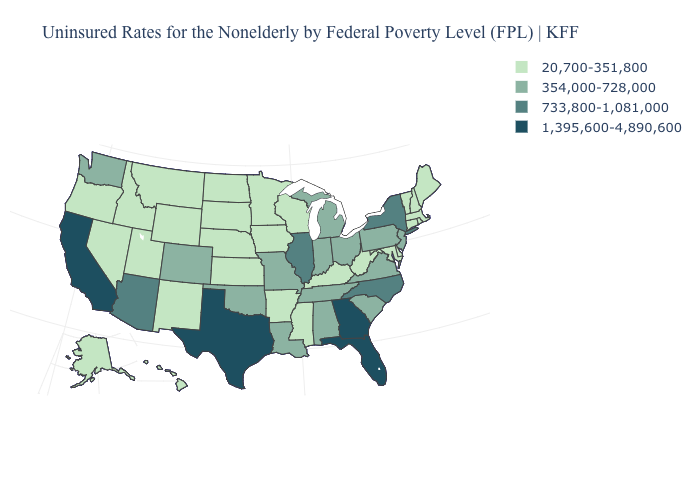Name the states that have a value in the range 354,000-728,000?
Be succinct. Alabama, Colorado, Indiana, Louisiana, Michigan, Missouri, New Jersey, Ohio, Oklahoma, Pennsylvania, South Carolina, Tennessee, Virginia, Washington. Name the states that have a value in the range 354,000-728,000?
Short answer required. Alabama, Colorado, Indiana, Louisiana, Michigan, Missouri, New Jersey, Ohio, Oklahoma, Pennsylvania, South Carolina, Tennessee, Virginia, Washington. Name the states that have a value in the range 1,395,600-4,890,600?
Keep it brief. California, Florida, Georgia, Texas. What is the value of Colorado?
Write a very short answer. 354,000-728,000. What is the value of Idaho?
Be succinct. 20,700-351,800. Name the states that have a value in the range 1,395,600-4,890,600?
Keep it brief. California, Florida, Georgia, Texas. What is the highest value in the USA?
Give a very brief answer. 1,395,600-4,890,600. What is the lowest value in the USA?
Short answer required. 20,700-351,800. Among the states that border Colorado , which have the lowest value?
Answer briefly. Kansas, Nebraska, New Mexico, Utah, Wyoming. What is the value of Idaho?
Be succinct. 20,700-351,800. What is the highest value in the West ?
Be succinct. 1,395,600-4,890,600. Which states have the lowest value in the USA?
Keep it brief. Alaska, Arkansas, Connecticut, Delaware, Hawaii, Idaho, Iowa, Kansas, Kentucky, Maine, Maryland, Massachusetts, Minnesota, Mississippi, Montana, Nebraska, Nevada, New Hampshire, New Mexico, North Dakota, Oregon, Rhode Island, South Dakota, Utah, Vermont, West Virginia, Wisconsin, Wyoming. Among the states that border North Dakota , which have the lowest value?
Keep it brief. Minnesota, Montana, South Dakota. What is the highest value in states that border New York?
Quick response, please. 354,000-728,000. Name the states that have a value in the range 20,700-351,800?
Keep it brief. Alaska, Arkansas, Connecticut, Delaware, Hawaii, Idaho, Iowa, Kansas, Kentucky, Maine, Maryland, Massachusetts, Minnesota, Mississippi, Montana, Nebraska, Nevada, New Hampshire, New Mexico, North Dakota, Oregon, Rhode Island, South Dakota, Utah, Vermont, West Virginia, Wisconsin, Wyoming. 